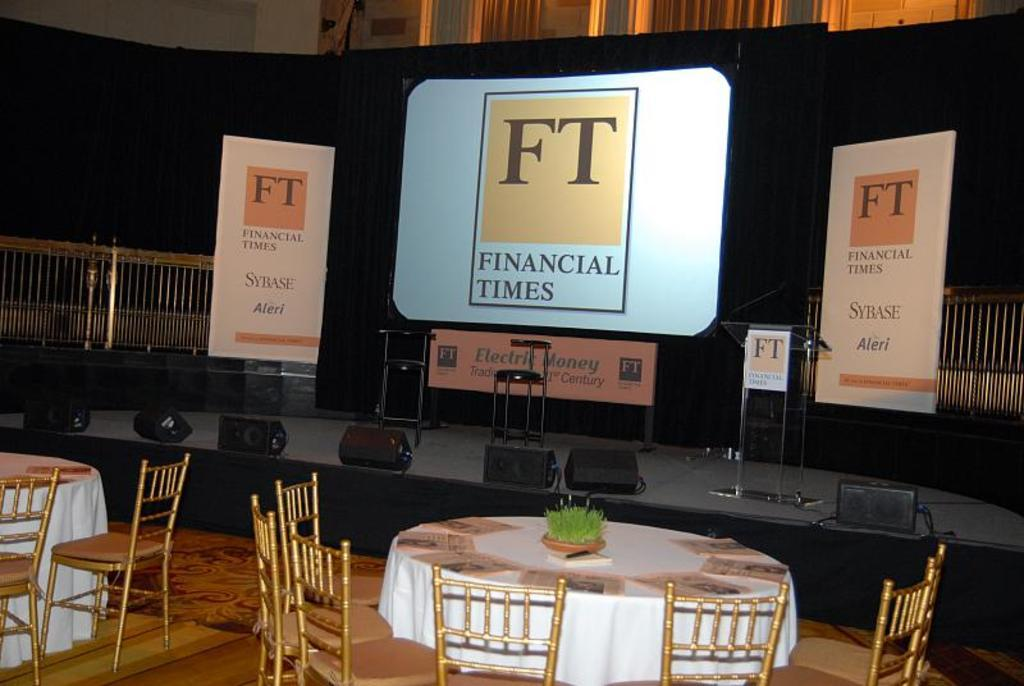<image>
Provide a brief description of the given image. a presentation with Financial Times at the top 